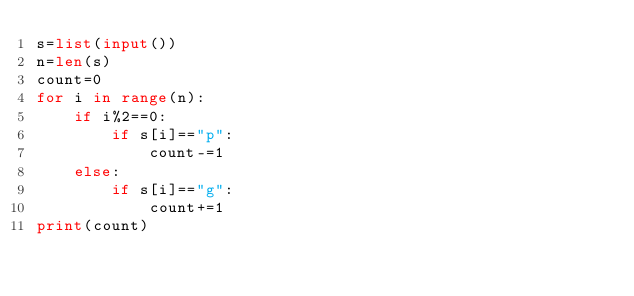<code> <loc_0><loc_0><loc_500><loc_500><_Python_>s=list(input())
n=len(s)
count=0
for i in range(n):
    if i%2==0:
        if s[i]=="p":
            count-=1
    else:
        if s[i]=="g":
            count+=1
print(count)</code> 